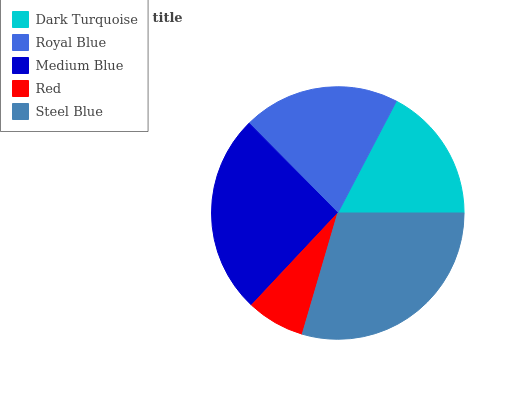Is Red the minimum?
Answer yes or no. Yes. Is Steel Blue the maximum?
Answer yes or no. Yes. Is Royal Blue the minimum?
Answer yes or no. No. Is Royal Blue the maximum?
Answer yes or no. No. Is Royal Blue greater than Dark Turquoise?
Answer yes or no. Yes. Is Dark Turquoise less than Royal Blue?
Answer yes or no. Yes. Is Dark Turquoise greater than Royal Blue?
Answer yes or no. No. Is Royal Blue less than Dark Turquoise?
Answer yes or no. No. Is Royal Blue the high median?
Answer yes or no. Yes. Is Royal Blue the low median?
Answer yes or no. Yes. Is Red the high median?
Answer yes or no. No. Is Steel Blue the low median?
Answer yes or no. No. 